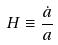Convert formula to latex. <formula><loc_0><loc_0><loc_500><loc_500>H \equiv \frac { \dot { a } } { a }</formula> 